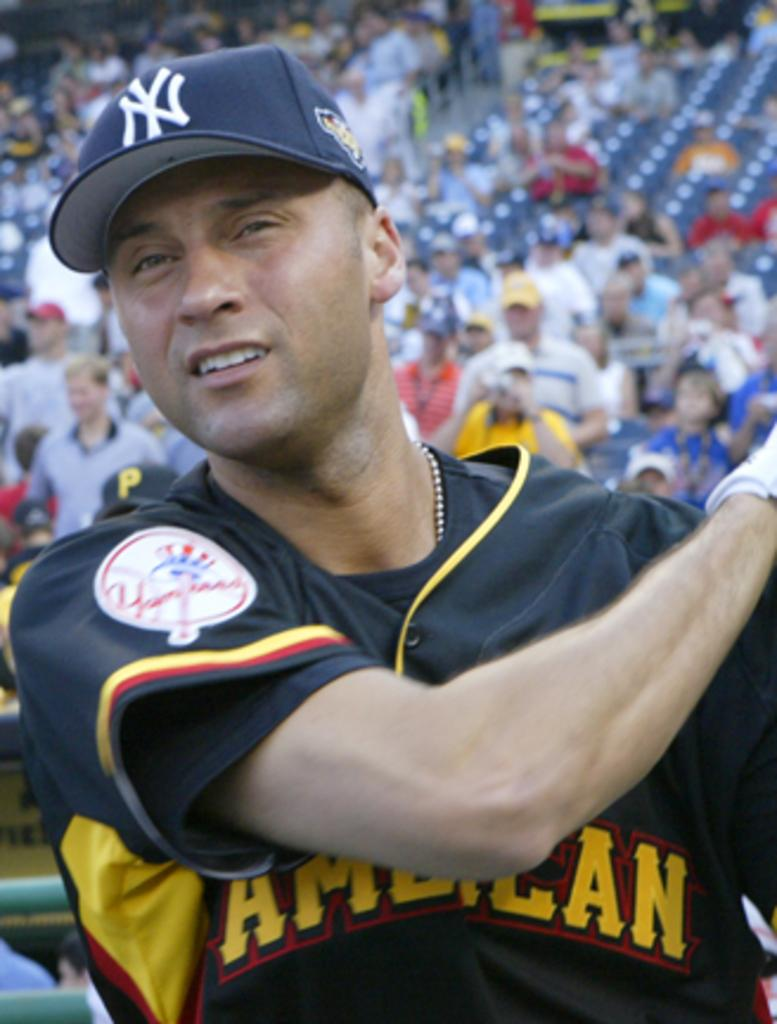<image>
Summarize the visual content of the image. Yankee baseball player Derek Jeter is up to bat, he is wearing a blue uniform with white NY on cap and yellow wording on shirt spelling out: AMERICAN. 